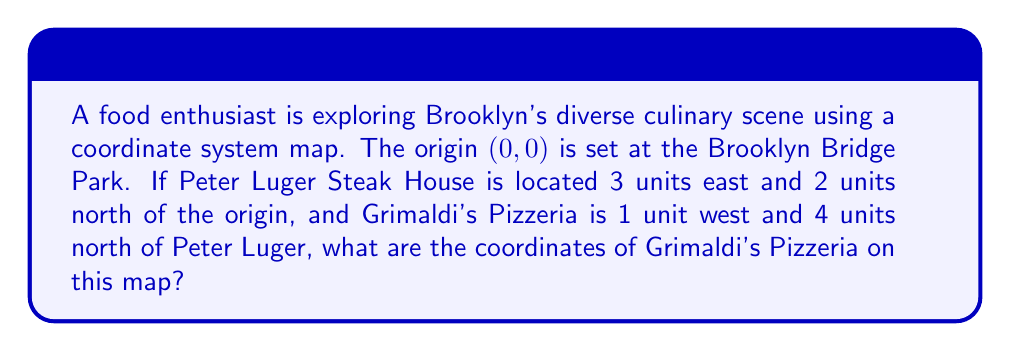Could you help me with this problem? Let's approach this step-by-step:

1. First, we need to identify the coordinates of Peter Luger Steak House:
   - It's 3 units east (positive x-direction) and 2 units north (positive y-direction) from the origin.
   - So, Peter Luger's coordinates are (3, 2).

2. Now, we need to find Grimaldi's location relative to Peter Luger:
   - It's 1 unit west (negative x-direction) and 4 units north (positive y-direction) from Peter Luger.

3. To find Grimaldi's coordinates, we need to add these relative positions to Peter Luger's coordinates:
   - x-coordinate: $3 + (-1) = 2$
   - y-coordinate: $2 + 4 = 6$

4. We can verify this mathematically:
   $$\begin{align}
   x_{Grimaldi's} &= x_{Peter Luger} + \text{x-displacement} \\
   &= 3 + (-1) = 2 \\
   y_{Grimaldi's} &= y_{Peter Luger} + \text{y-displacement} \\
   &= 2 + 4 = 6
   \end{align}$$

Therefore, the coordinates of Grimaldi's Pizzeria are (2, 6) on this Brooklyn culinary map.
Answer: (2, 6) 